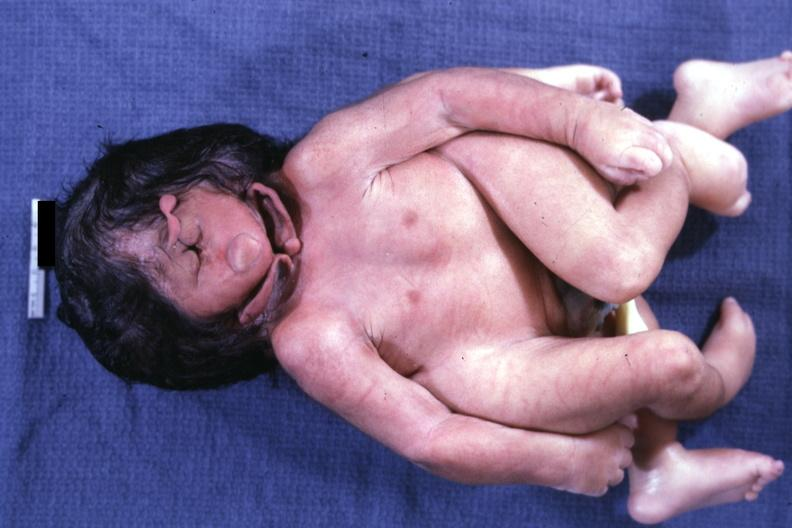does this image show anterior lateral view of this monster?
Answer the question using a single word or phrase. Yes 